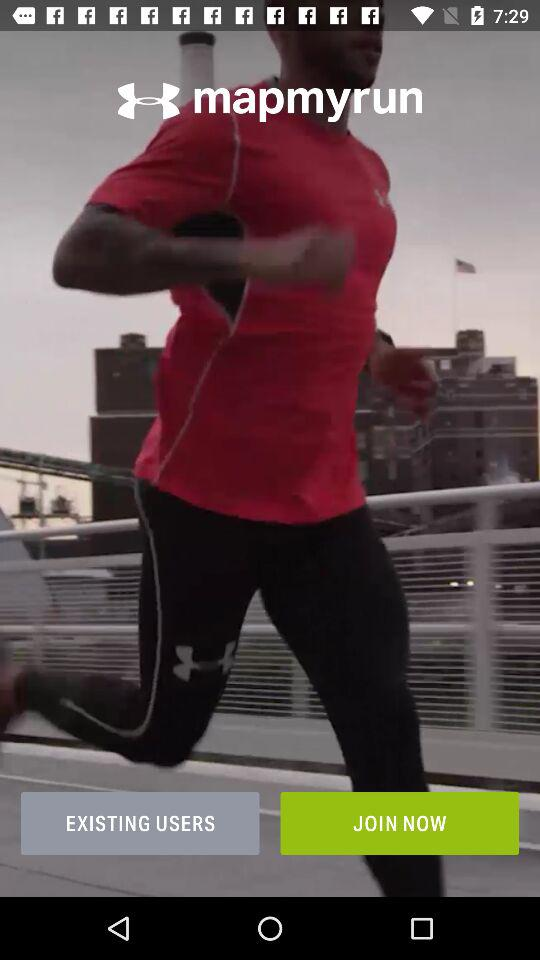What is the application name? The application name is "mapmyrun". 